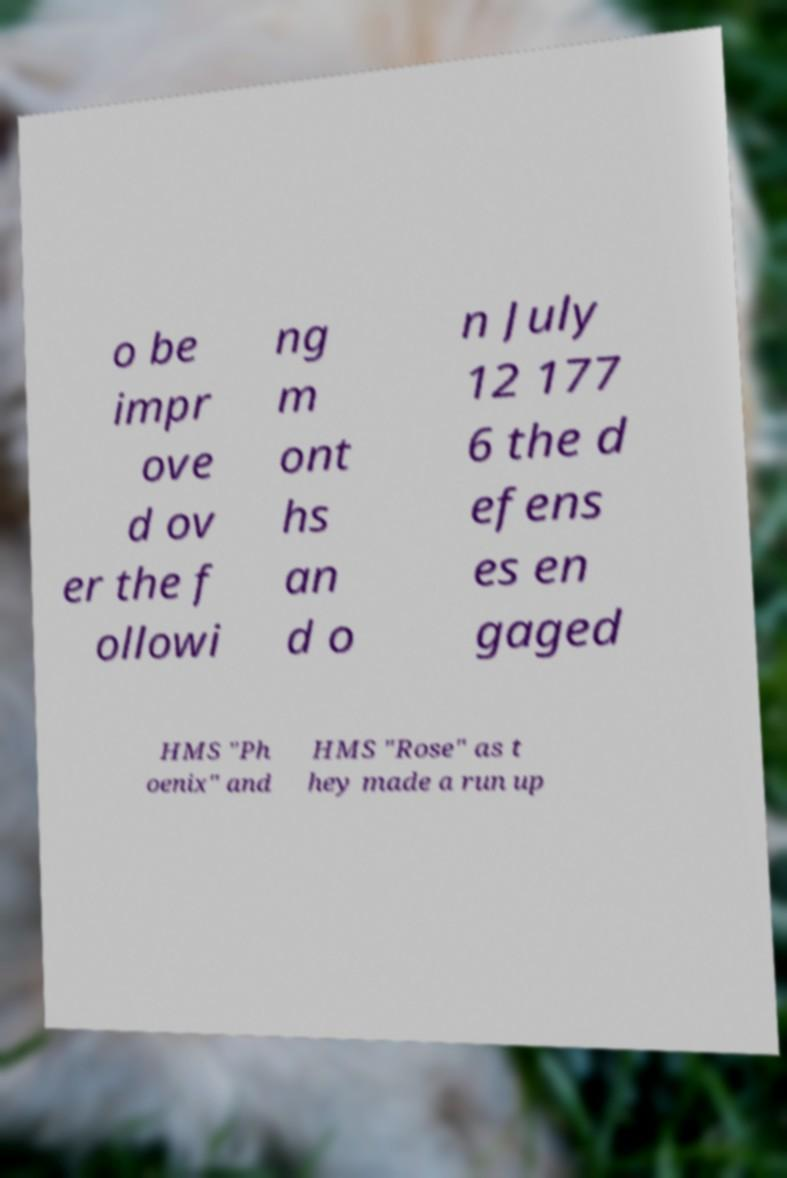Please identify and transcribe the text found in this image. o be impr ove d ov er the f ollowi ng m ont hs an d o n July 12 177 6 the d efens es en gaged HMS "Ph oenix" and HMS "Rose" as t hey made a run up 